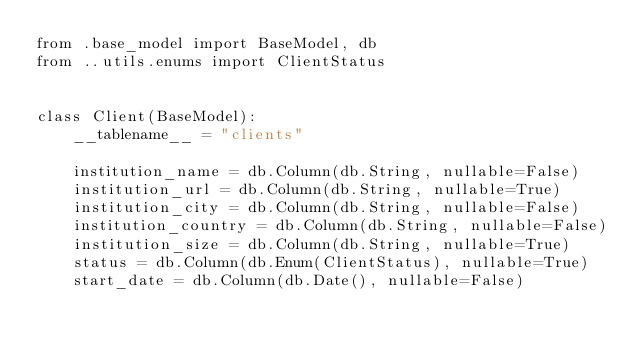Convert code to text. <code><loc_0><loc_0><loc_500><loc_500><_Python_>from .base_model import BaseModel, db
from ..utils.enums import ClientStatus


class Client(BaseModel):
    __tablename__ = "clients"

    institution_name = db.Column(db.String, nullable=False)
    institution_url = db.Column(db.String, nullable=True)
    institution_city = db.Column(db.String, nullable=False)
    institution_country = db.Column(db.String, nullable=False)
    institution_size = db.Column(db.String, nullable=True)
    status = db.Column(db.Enum(ClientStatus), nullable=True)
    start_date = db.Column(db.Date(), nullable=False)
</code> 